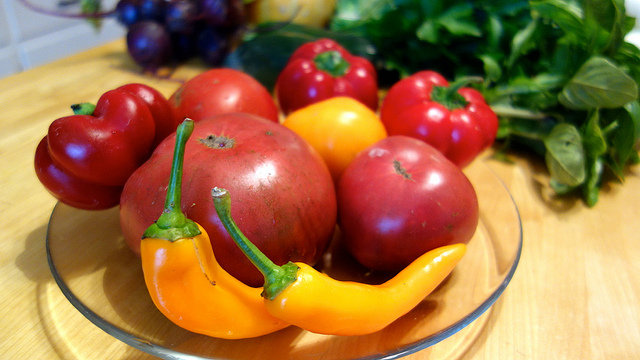What variety of vegetables are present in the bowl? The bowl contains an assortment of vegetables including bell peppers in red and yellow, tomatoes, and what appears to be a yellow chili pepper. Additionally, there are leafy greens in the background which could be herbs or salad greens. 